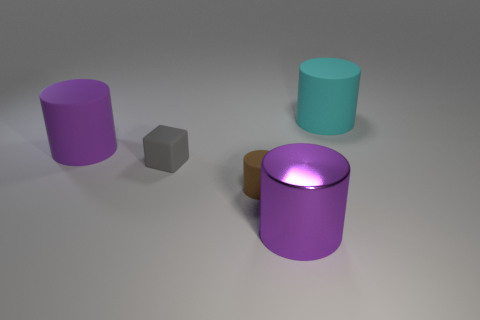What is the color of the large thing on the left side of the tiny gray matte object? The large object to the left of the tiny gray matte object is a cylinder with a rich purple color, exhibiting a smooth surface that reflects some of the light, creating a slight gradient effect on its side. 